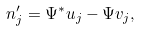Convert formula to latex. <formula><loc_0><loc_0><loc_500><loc_500>n _ { j } ^ { \prime } = \Psi ^ { * } u _ { j } - \Psi v _ { j } ,</formula> 